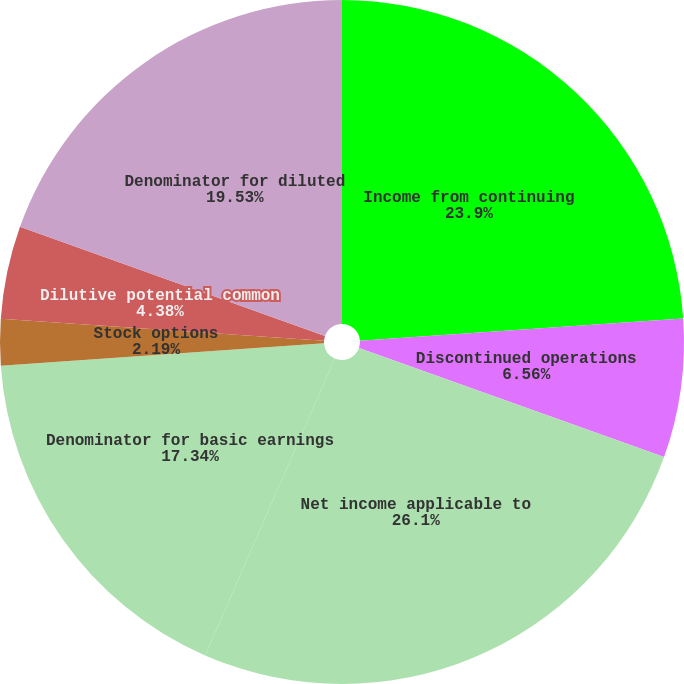Convert chart to OTSL. <chart><loc_0><loc_0><loc_500><loc_500><pie_chart><fcel>Income from continuing<fcel>Discontinued operations<fcel>Net income applicable to<fcel>Denominator for basic earnings<fcel>Stock options<fcel>Restricted stock awards<fcel>Dilutive potential common<fcel>Denominator for diluted<nl><fcel>23.9%<fcel>6.56%<fcel>26.09%<fcel>17.34%<fcel>2.19%<fcel>0.0%<fcel>4.38%<fcel>19.53%<nl></chart> 